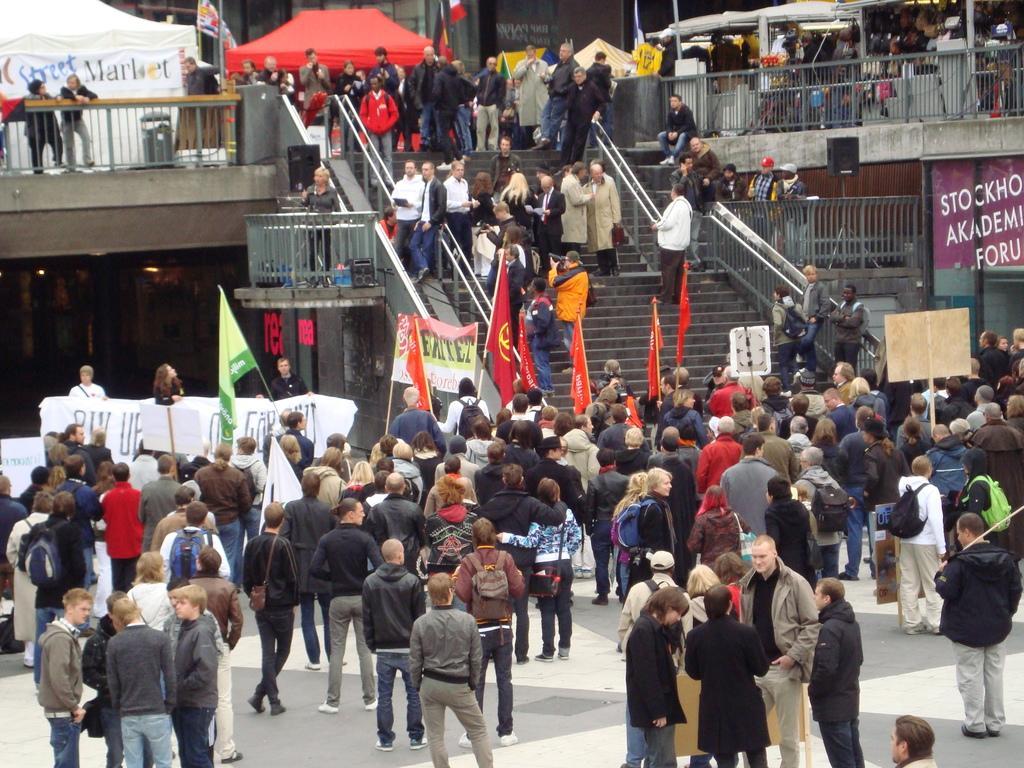In one or two sentences, can you explain what this image depicts? In this image I can see number of people are standing. I can also see stairs in the centre and on the both side of it I can see number of boards. On these words I can see something is written. I can also see number of flags in the front and on the top side of this image. I can also see a red colour tent on the top left side of this image. 